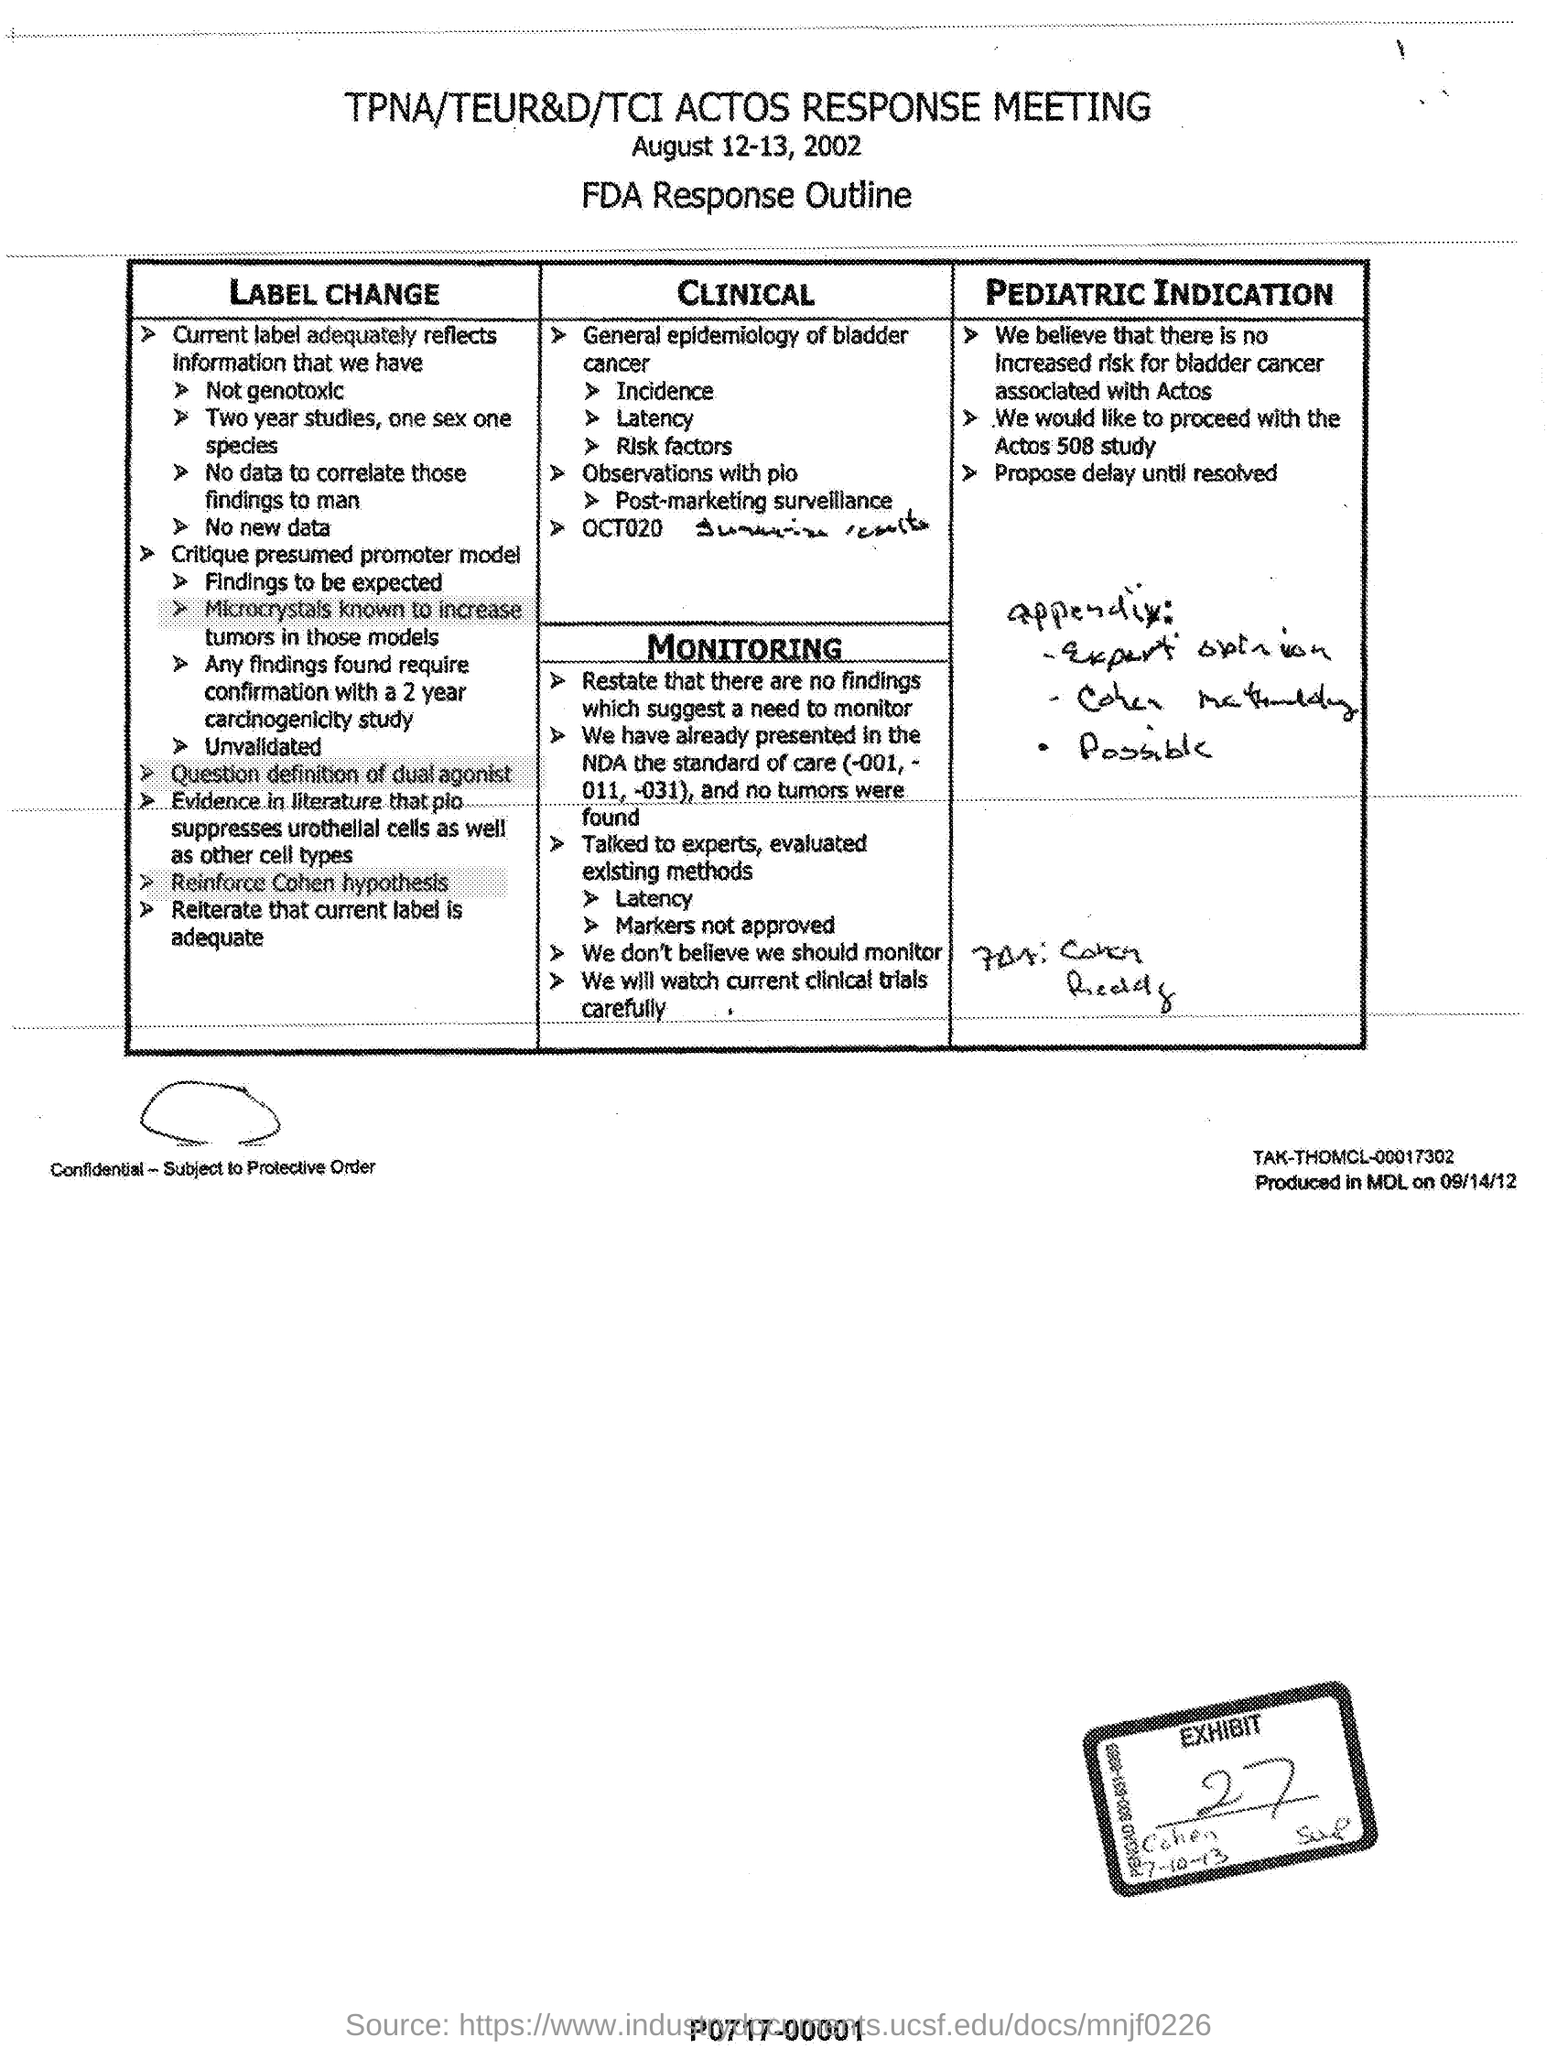What is the heading of the document?
Your response must be concise. TPNA/TEUR&D/TCI ACTOS RESPONSE MEETING. What is the date mentioned?
Ensure brevity in your answer.  August 12-13, 2002. What is the heading of the handwritten words in Pediatric Indication?
Keep it short and to the point. Appendix. 